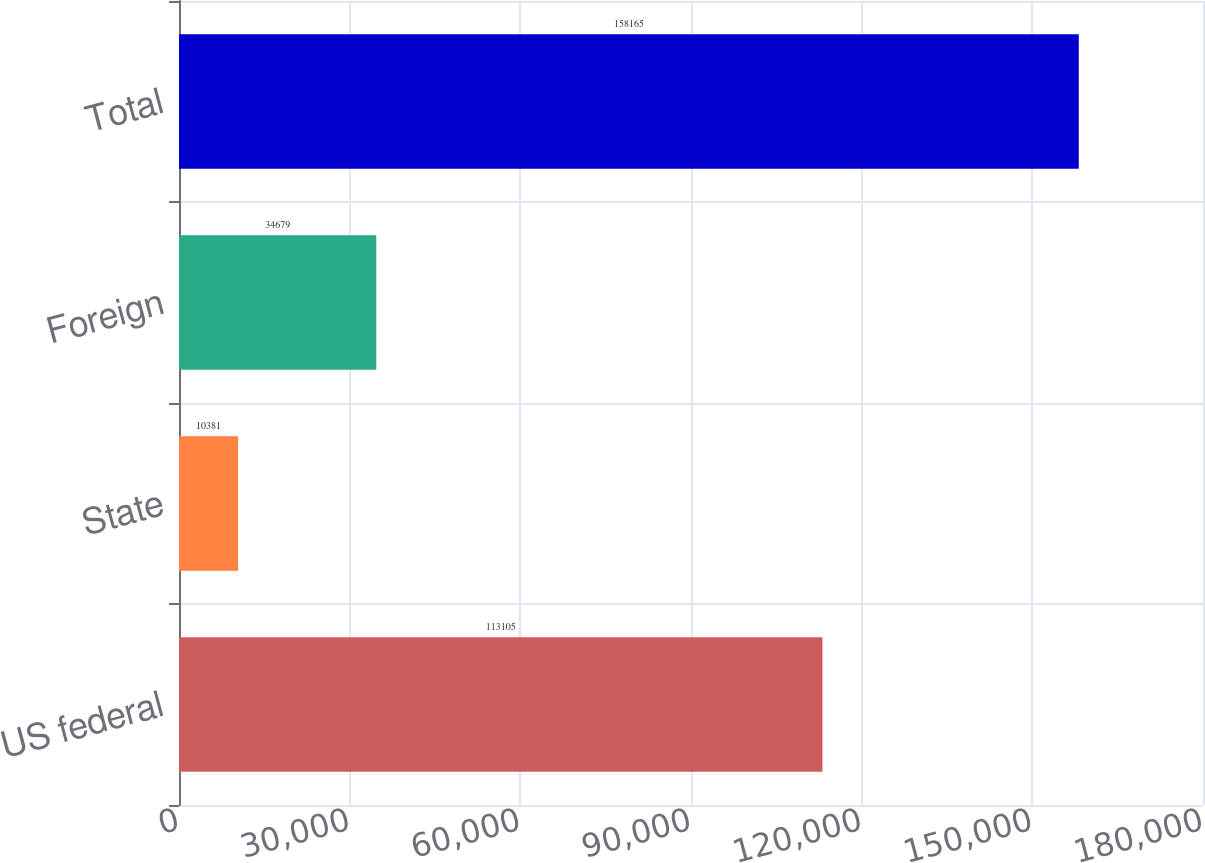Convert chart to OTSL. <chart><loc_0><loc_0><loc_500><loc_500><bar_chart><fcel>US federal<fcel>State<fcel>Foreign<fcel>Total<nl><fcel>113105<fcel>10381<fcel>34679<fcel>158165<nl></chart> 